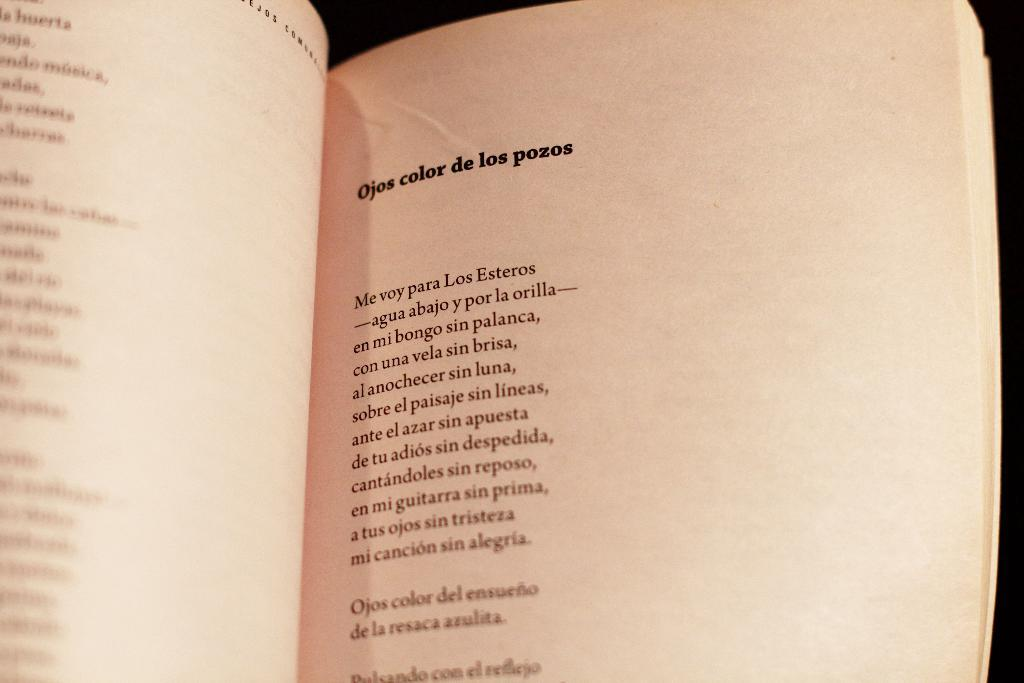What is the main object in the picture? There is an open book in the picture. What else can be seen in the picture besides the open book? There are papers with writing on them in the picture. What advice can be seen on the ladybug in the picture? There is no ladybug present in the picture, so no advice can be seen on it. 